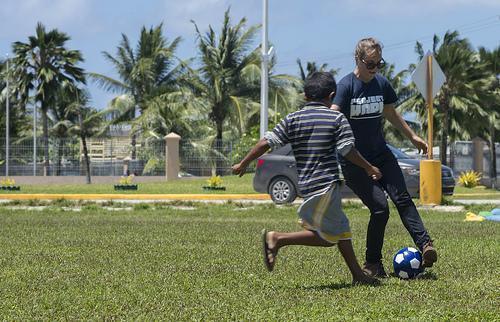How many people are on the picture?
Give a very brief answer. 2. 